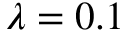Convert formula to latex. <formula><loc_0><loc_0><loc_500><loc_500>\lambda = 0 . 1</formula> 